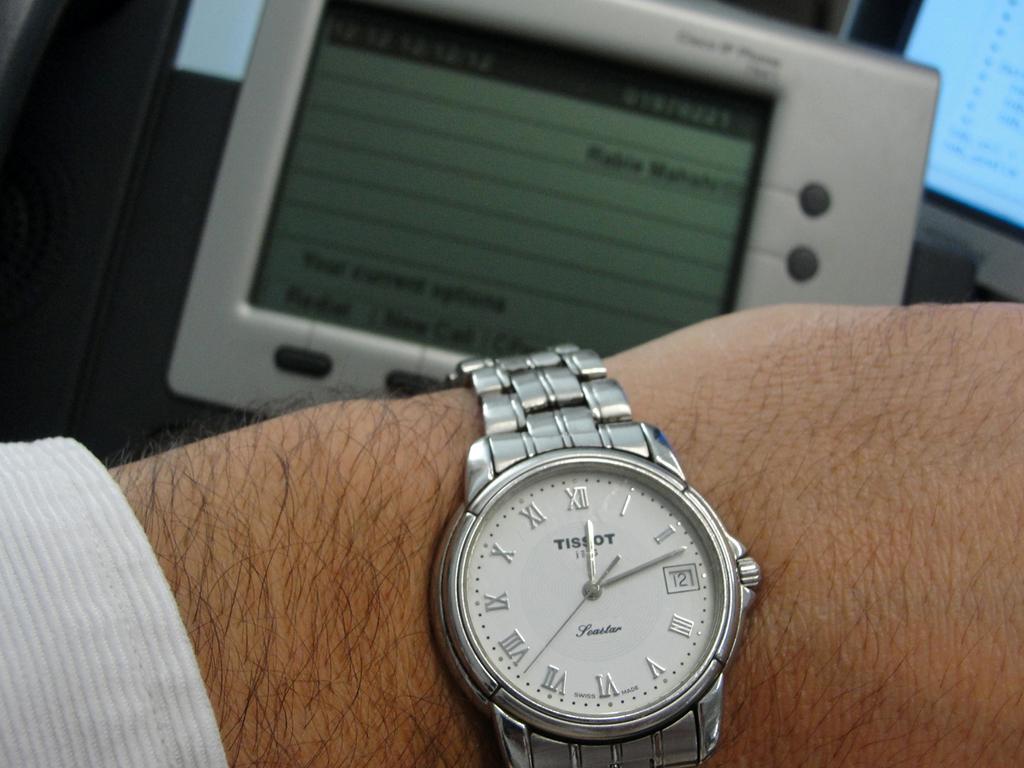What time is it on the watch?
Provide a short and direct response. 12:12. What brand is the watch?
Give a very brief answer. Tissot. 